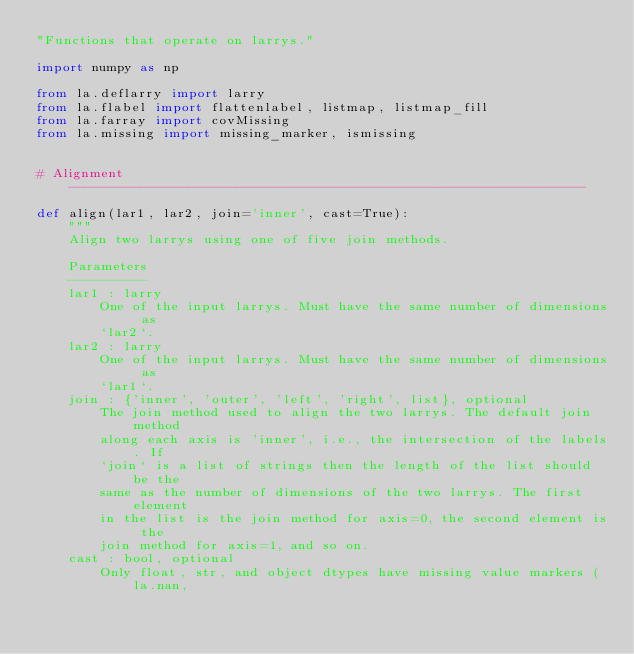<code> <loc_0><loc_0><loc_500><loc_500><_Python_>"Functions that operate on larrys."

import numpy as np

from la.deflarry import larry
from la.flabel import flattenlabel, listmap, listmap_fill
from la.farray import covMissing
from la.missing import missing_marker, ismissing


# Alignment -----------------------------------------------------------------

def align(lar1, lar2, join='inner', cast=True):    
    """
    Align two larrys using one of five join methods.
    
    Parameters
    ----------
    lar1 : larry
        One of the input larrys. Must have the same number of dimensions as
        `lar2`.
    lar2 : larry
        One of the input larrys. Must have the same number of dimensions as
        `lar1`.
    join : {'inner', 'outer', 'left', 'right', list}, optional
        The join method used to align the two larrys. The default join method
        along each axis is 'inner', i.e., the intersection of the labels. If
        `join` is a list of strings then the length of the list should be the 
        same as the number of dimensions of the two larrys. The first element
        in the list is the join method for axis=0, the second element is the
        join method for axis=1, and so on.
    cast : bool, optional
        Only float, str, and object dtypes have missing value markers (la.nan,</code> 